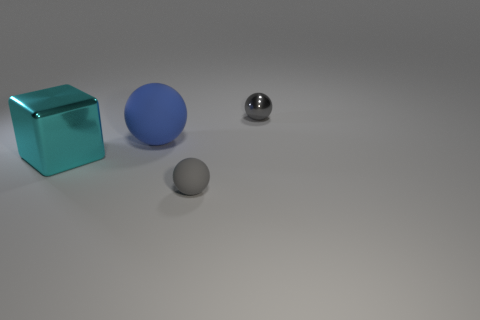What is the blue object made of?
Keep it short and to the point. Rubber. The gray thing on the left side of the tiny object behind the large cyan metal object is what shape?
Your response must be concise. Sphere. There is a tiny object that is in front of the gray shiny thing; what shape is it?
Your response must be concise. Sphere. How many big metal blocks are the same color as the tiny rubber ball?
Keep it short and to the point. 0. The metal sphere is what color?
Offer a very short reply. Gray. There is a blue rubber sphere left of the small matte thing; how many shiny objects are in front of it?
Make the answer very short. 1. Do the cyan object and the gray sphere in front of the small metallic object have the same size?
Offer a very short reply. No. Does the metal ball have the same size as the cyan block?
Give a very brief answer. No. Are there any red matte cubes that have the same size as the blue object?
Your answer should be very brief. No. There is a large thing right of the big cyan object; what is its material?
Your answer should be compact. Rubber. 